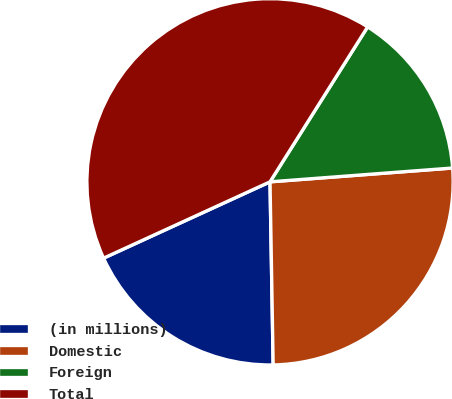Convert chart to OTSL. <chart><loc_0><loc_0><loc_500><loc_500><pie_chart><fcel>(in millions)<fcel>Domestic<fcel>Foreign<fcel>Total<nl><fcel>18.43%<fcel>25.93%<fcel>14.85%<fcel>40.79%<nl></chart> 